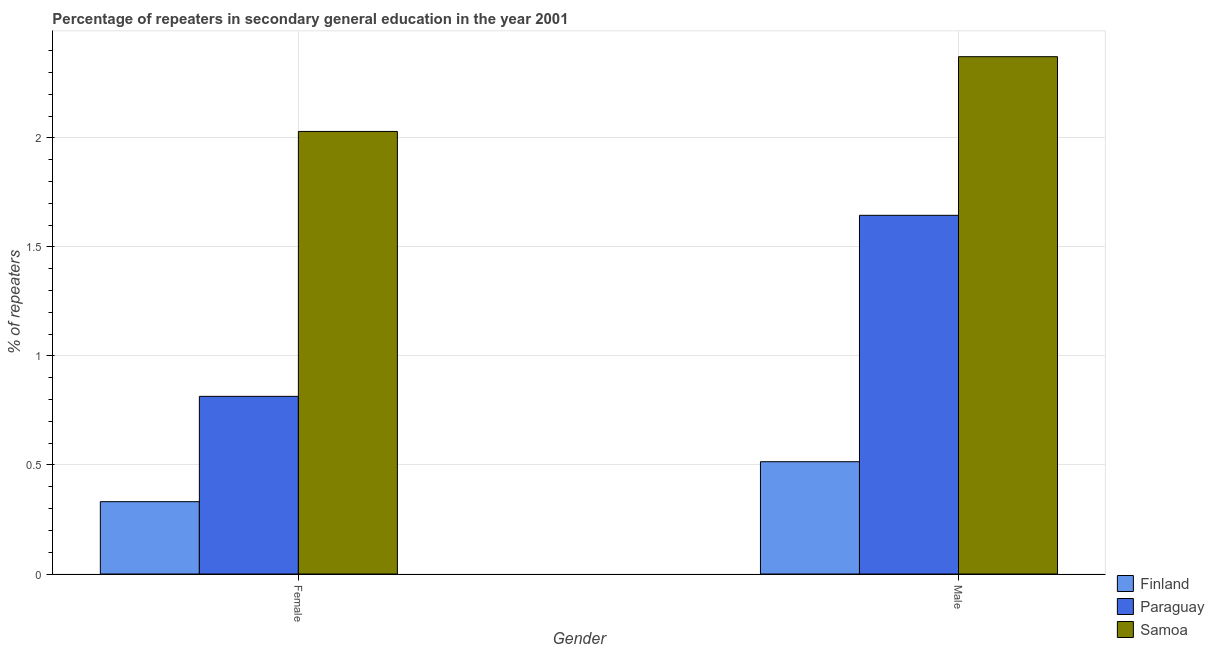How many groups of bars are there?
Make the answer very short. 2. Are the number of bars per tick equal to the number of legend labels?
Offer a very short reply. Yes. How many bars are there on the 1st tick from the left?
Offer a terse response. 3. How many bars are there on the 1st tick from the right?
Ensure brevity in your answer.  3. What is the label of the 1st group of bars from the left?
Your response must be concise. Female. What is the percentage of female repeaters in Paraguay?
Offer a terse response. 0.81. Across all countries, what is the maximum percentage of male repeaters?
Your answer should be compact. 2.37. Across all countries, what is the minimum percentage of male repeaters?
Your answer should be compact. 0.51. In which country was the percentage of male repeaters maximum?
Your answer should be compact. Samoa. In which country was the percentage of female repeaters minimum?
Keep it short and to the point. Finland. What is the total percentage of male repeaters in the graph?
Give a very brief answer. 4.53. What is the difference between the percentage of male repeaters in Finland and that in Samoa?
Offer a terse response. -1.86. What is the difference between the percentage of male repeaters in Finland and the percentage of female repeaters in Samoa?
Give a very brief answer. -1.51. What is the average percentage of male repeaters per country?
Provide a short and direct response. 1.51. What is the difference between the percentage of male repeaters and percentage of female repeaters in Paraguay?
Provide a short and direct response. 0.83. What is the ratio of the percentage of female repeaters in Finland to that in Samoa?
Keep it short and to the point. 0.16. What does the 3rd bar from the right in Male represents?
Provide a short and direct response. Finland. What is the difference between two consecutive major ticks on the Y-axis?
Your answer should be very brief. 0.5. Are the values on the major ticks of Y-axis written in scientific E-notation?
Your answer should be compact. No. Does the graph contain any zero values?
Make the answer very short. No. How many legend labels are there?
Your answer should be very brief. 3. What is the title of the graph?
Provide a succinct answer. Percentage of repeaters in secondary general education in the year 2001. Does "Latin America(developing only)" appear as one of the legend labels in the graph?
Keep it short and to the point. No. What is the label or title of the Y-axis?
Provide a succinct answer. % of repeaters. What is the % of repeaters in Finland in Female?
Offer a very short reply. 0.33. What is the % of repeaters in Paraguay in Female?
Provide a succinct answer. 0.81. What is the % of repeaters in Samoa in Female?
Keep it short and to the point. 2.03. What is the % of repeaters in Finland in Male?
Make the answer very short. 0.51. What is the % of repeaters of Paraguay in Male?
Ensure brevity in your answer.  1.65. What is the % of repeaters of Samoa in Male?
Provide a succinct answer. 2.37. Across all Gender, what is the maximum % of repeaters of Finland?
Offer a terse response. 0.51. Across all Gender, what is the maximum % of repeaters in Paraguay?
Provide a succinct answer. 1.65. Across all Gender, what is the maximum % of repeaters in Samoa?
Your answer should be compact. 2.37. Across all Gender, what is the minimum % of repeaters of Finland?
Offer a terse response. 0.33. Across all Gender, what is the minimum % of repeaters in Paraguay?
Make the answer very short. 0.81. Across all Gender, what is the minimum % of repeaters of Samoa?
Your response must be concise. 2.03. What is the total % of repeaters in Finland in the graph?
Make the answer very short. 0.85. What is the total % of repeaters in Paraguay in the graph?
Offer a very short reply. 2.46. What is the total % of repeaters in Samoa in the graph?
Make the answer very short. 4.4. What is the difference between the % of repeaters in Finland in Female and that in Male?
Your answer should be very brief. -0.18. What is the difference between the % of repeaters of Paraguay in Female and that in Male?
Keep it short and to the point. -0.83. What is the difference between the % of repeaters in Samoa in Female and that in Male?
Give a very brief answer. -0.34. What is the difference between the % of repeaters of Finland in Female and the % of repeaters of Paraguay in Male?
Provide a succinct answer. -1.31. What is the difference between the % of repeaters of Finland in Female and the % of repeaters of Samoa in Male?
Ensure brevity in your answer.  -2.04. What is the difference between the % of repeaters of Paraguay in Female and the % of repeaters of Samoa in Male?
Your answer should be very brief. -1.56. What is the average % of repeaters of Finland per Gender?
Your response must be concise. 0.42. What is the average % of repeaters of Paraguay per Gender?
Your answer should be compact. 1.23. What is the average % of repeaters in Samoa per Gender?
Your response must be concise. 2.2. What is the difference between the % of repeaters in Finland and % of repeaters in Paraguay in Female?
Offer a very short reply. -0.48. What is the difference between the % of repeaters in Finland and % of repeaters in Samoa in Female?
Keep it short and to the point. -1.7. What is the difference between the % of repeaters in Paraguay and % of repeaters in Samoa in Female?
Your answer should be very brief. -1.21. What is the difference between the % of repeaters in Finland and % of repeaters in Paraguay in Male?
Your answer should be very brief. -1.13. What is the difference between the % of repeaters of Finland and % of repeaters of Samoa in Male?
Provide a short and direct response. -1.86. What is the difference between the % of repeaters of Paraguay and % of repeaters of Samoa in Male?
Make the answer very short. -0.73. What is the ratio of the % of repeaters of Finland in Female to that in Male?
Provide a short and direct response. 0.64. What is the ratio of the % of repeaters in Paraguay in Female to that in Male?
Offer a very short reply. 0.5. What is the ratio of the % of repeaters in Samoa in Female to that in Male?
Your answer should be compact. 0.86. What is the difference between the highest and the second highest % of repeaters of Finland?
Make the answer very short. 0.18. What is the difference between the highest and the second highest % of repeaters in Paraguay?
Provide a succinct answer. 0.83. What is the difference between the highest and the second highest % of repeaters of Samoa?
Keep it short and to the point. 0.34. What is the difference between the highest and the lowest % of repeaters of Finland?
Keep it short and to the point. 0.18. What is the difference between the highest and the lowest % of repeaters of Paraguay?
Keep it short and to the point. 0.83. What is the difference between the highest and the lowest % of repeaters of Samoa?
Provide a succinct answer. 0.34. 